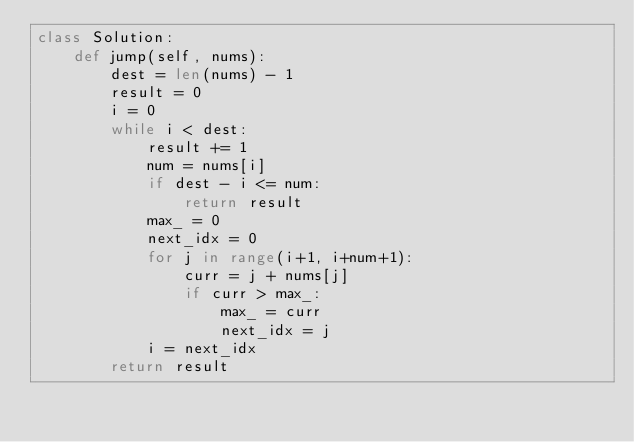Convert code to text. <code><loc_0><loc_0><loc_500><loc_500><_Python_>class Solution:
    def jump(self, nums):
        dest = len(nums) - 1
        result = 0
        i = 0
        while i < dest:
            result += 1
            num = nums[i]
            if dest - i <= num:
                return result
            max_ = 0
            next_idx = 0
            for j in range(i+1, i+num+1):
                curr = j + nums[j]
                if curr > max_:
                    max_ = curr
                    next_idx = j
            i = next_idx
        return result
</code> 